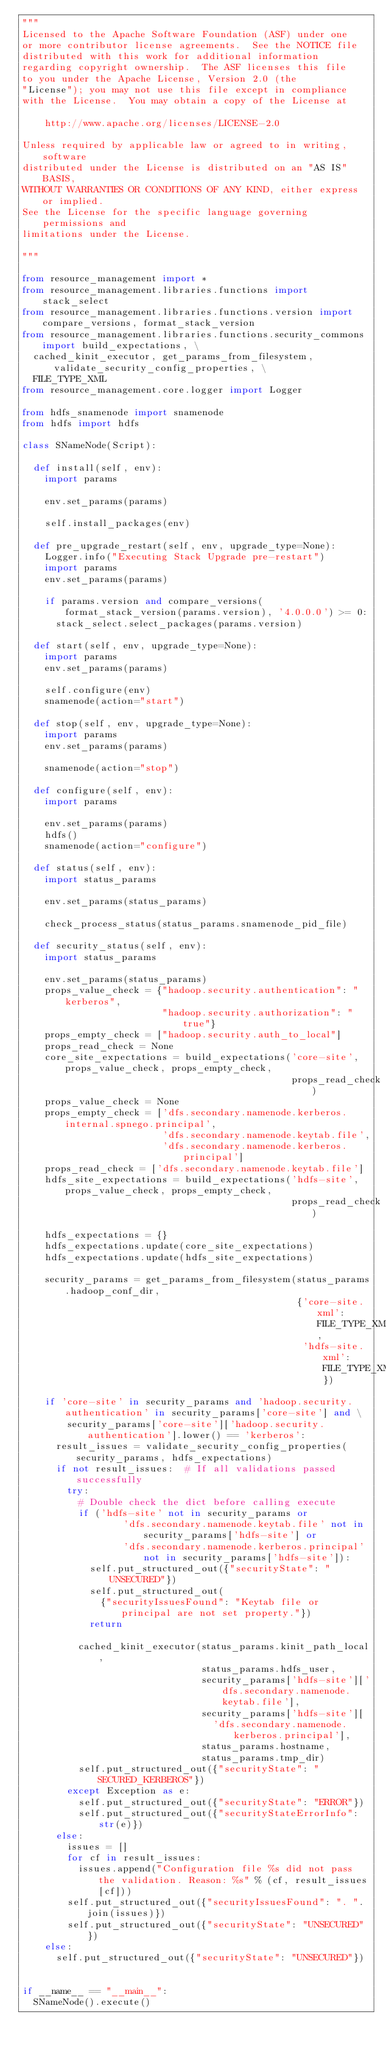Convert code to text. <code><loc_0><loc_0><loc_500><loc_500><_Python_>"""
Licensed to the Apache Software Foundation (ASF) under one
or more contributor license agreements.  See the NOTICE file
distributed with this work for additional information
regarding copyright ownership.  The ASF licenses this file
to you under the Apache License, Version 2.0 (the
"License"); you may not use this file except in compliance
with the License.  You may obtain a copy of the License at

    http://www.apache.org/licenses/LICENSE-2.0

Unless required by applicable law or agreed to in writing, software
distributed under the License is distributed on an "AS IS" BASIS,
WITHOUT WARRANTIES OR CONDITIONS OF ANY KIND, either express or implied.
See the License for the specific language governing permissions and
limitations under the License.

"""

from resource_management import *
from resource_management.libraries.functions import stack_select
from resource_management.libraries.functions.version import compare_versions, format_stack_version
from resource_management.libraries.functions.security_commons import build_expectations, \
  cached_kinit_executor, get_params_from_filesystem, validate_security_config_properties, \
  FILE_TYPE_XML
from resource_management.core.logger import Logger

from hdfs_snamenode import snamenode
from hdfs import hdfs

class SNameNode(Script):

  def install(self, env):
    import params

    env.set_params(params)

    self.install_packages(env)

  def pre_upgrade_restart(self, env, upgrade_type=None):
    Logger.info("Executing Stack Upgrade pre-restart")
    import params
    env.set_params(params)

    if params.version and compare_versions(format_stack_version(params.version), '4.0.0.0') >= 0:
      stack_select.select_packages(params.version)

  def start(self, env, upgrade_type=None):
    import params
    env.set_params(params)

    self.configure(env)
    snamenode(action="start")

  def stop(self, env, upgrade_type=None):
    import params
    env.set_params(params)

    snamenode(action="stop")

  def configure(self, env):
    import params

    env.set_params(params)
    hdfs()
    snamenode(action="configure")

  def status(self, env):
    import status_params

    env.set_params(status_params)

    check_process_status(status_params.snamenode_pid_file)

  def security_status(self, env):
    import status_params

    env.set_params(status_params)
    props_value_check = {"hadoop.security.authentication": "kerberos",
                         "hadoop.security.authorization": "true"}
    props_empty_check = ["hadoop.security.auth_to_local"]
    props_read_check = None
    core_site_expectations = build_expectations('core-site', props_value_check, props_empty_check,
                                                props_read_check)
    props_value_check = None
    props_empty_check = ['dfs.secondary.namenode.kerberos.internal.spnego.principal',
                         'dfs.secondary.namenode.keytab.file',
                         'dfs.secondary.namenode.kerberos.principal']
    props_read_check = ['dfs.secondary.namenode.keytab.file']
    hdfs_site_expectations = build_expectations('hdfs-site', props_value_check, props_empty_check,
                                                props_read_check)

    hdfs_expectations = {}
    hdfs_expectations.update(core_site_expectations)
    hdfs_expectations.update(hdfs_site_expectations)

    security_params = get_params_from_filesystem(status_params.hadoop_conf_dir,
                                                 {'core-site.xml': FILE_TYPE_XML,
                                                  'hdfs-site.xml': FILE_TYPE_XML})

    if 'core-site' in security_params and 'hadoop.security.authentication' in security_params['core-site'] and \
        security_params['core-site']['hadoop.security.authentication'].lower() == 'kerberos':
      result_issues = validate_security_config_properties(security_params, hdfs_expectations)
      if not result_issues:  # If all validations passed successfully
        try:
          # Double check the dict before calling execute
          if ('hdfs-site' not in security_params or
                  'dfs.secondary.namenode.keytab.file' not in security_params['hdfs-site'] or
                  'dfs.secondary.namenode.kerberos.principal' not in security_params['hdfs-site']):
            self.put_structured_out({"securityState": "UNSECURED"})
            self.put_structured_out(
              {"securityIssuesFound": "Keytab file or principal are not set property."})
            return

          cached_kinit_executor(status_params.kinit_path_local,
                                status_params.hdfs_user,
                                security_params['hdfs-site']['dfs.secondary.namenode.keytab.file'],
                                security_params['hdfs-site'][
                                  'dfs.secondary.namenode.kerberos.principal'],
                                status_params.hostname,
                                status_params.tmp_dir)
          self.put_structured_out({"securityState": "SECURED_KERBEROS"})
        except Exception as e:
          self.put_structured_out({"securityState": "ERROR"})
          self.put_structured_out({"securityStateErrorInfo": str(e)})
      else:
        issues = []
        for cf in result_issues:
          issues.append("Configuration file %s did not pass the validation. Reason: %s" % (cf, result_issues[cf]))
        self.put_structured_out({"securityIssuesFound": ". ".join(issues)})
        self.put_structured_out({"securityState": "UNSECURED"})
    else:
      self.put_structured_out({"securityState": "UNSECURED"})


if __name__ == "__main__":
  SNameNode().execute()
</code> 